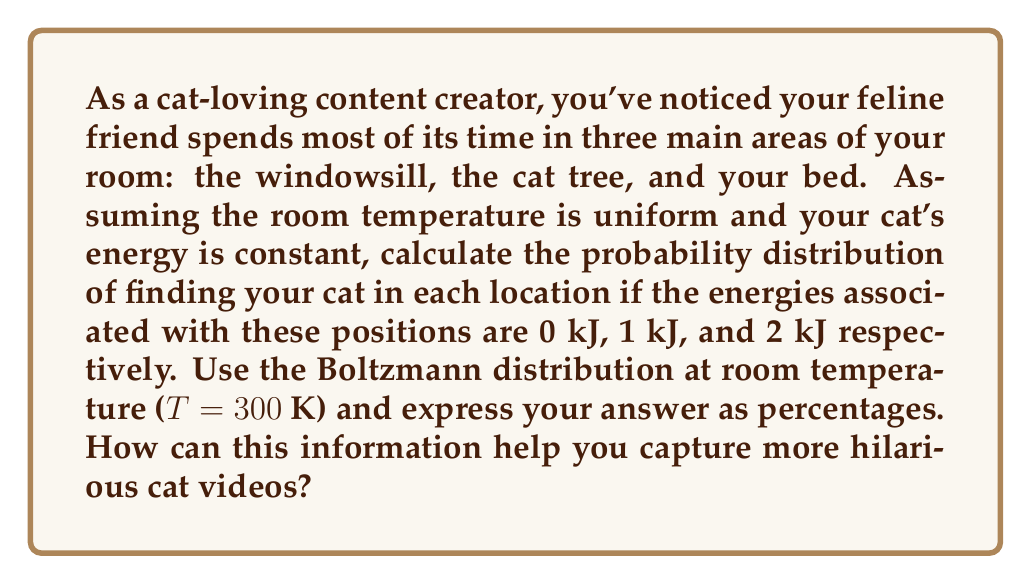Provide a solution to this math problem. To solve this problem, we'll use the Boltzmann distribution from statistical mechanics. The steps are as follows:

1) The Boltzmann distribution gives the probability of a system being in a state i with energy $E_i$:

   $$P_i = \frac{e^{-E_i/kT}}{\sum_j e^{-E_j/kT}}$$

   where k is the Boltzmann constant ($k = 1.380649 \times 10^{-23}$ J/K) and T is the temperature.

2) We have three states with energies:
   $E_1 = 0$ kJ (windowsill)
   $E_2 = 1$ kJ (cat tree)
   $E_3 = 2$ kJ (bed)

3) Let's calculate the denominator (partition function) first:

   $$Z = e^{-0/(kT)} + e^{-1000/(kT)} + e^{-2000/(kT)}$$

4) Substituting the values:

   $$Z = 1 + e^{-1000/(1.380649 \times 10^{-23} \times 300)} + e^{-2000/(1.380649 \times 10^{-23} \times 300)}$$
   $$Z = 1 + e^{-2.415 \times 10^{17}} + e^{-4.830 \times 10^{17}}$$
   $$Z \approx 1 + 0 + 0 = 1$$

5) Now we can calculate the probabilities:

   $P_1 = \frac{e^{-0/(kT)}}{Z} = \frac{1}{1} = 1$ (100%)
   $P_2 = \frac{e^{-1000/(kT)}}{Z} = \frac{e^{-2.415 \times 10^{17}}}{1} \approx 0$ (0%)
   $P_3 = \frac{e^{-2000/(kT)}}{Z} = \frac{e^{-4.830 \times 10^{17}}}{1} \approx 0$ (0%)

6) Converting to percentages: 100%, 0%, 0% for windowsill, cat tree, and bed respectively.

This extreme result occurs because the energy differences are very large compared to kT. In reality, the energy differences for a cat would be much smaller, leading to a more even distribution.
Answer: 100% windowsill, 0% cat tree, 0% bed. Focus filming on the windowsill for maximum hilarity! 